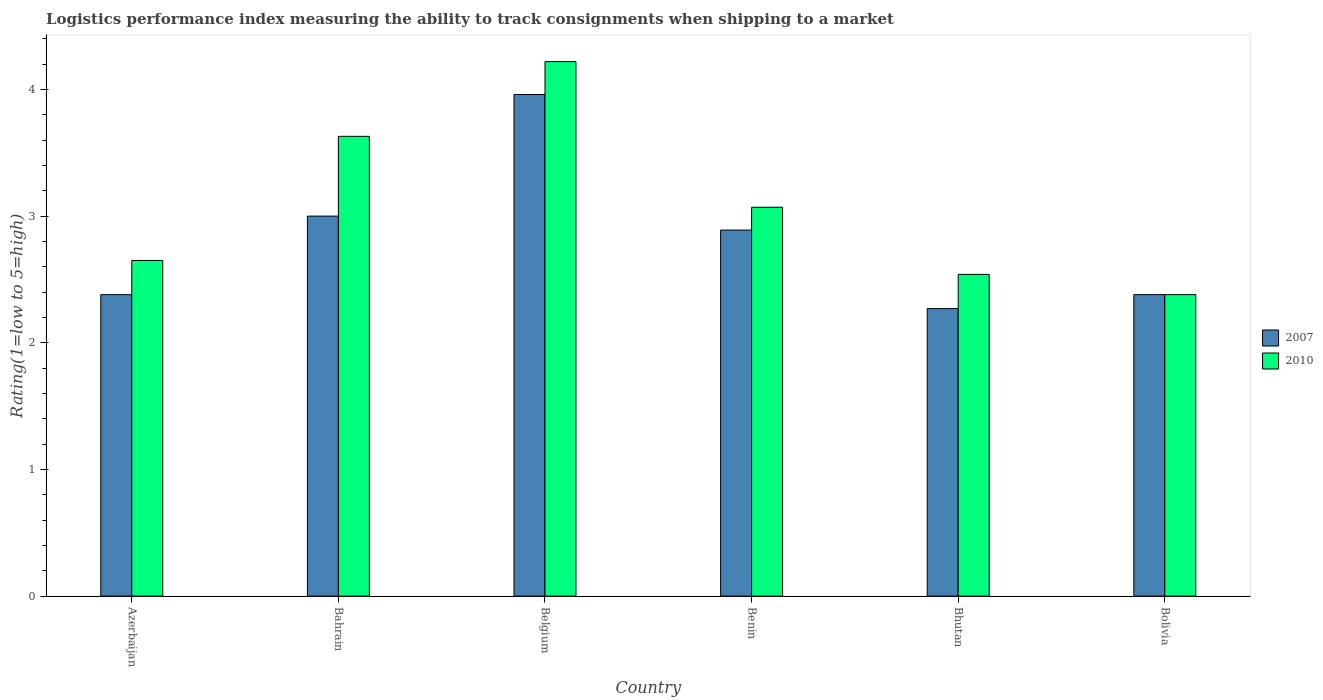How many groups of bars are there?
Provide a succinct answer. 6. How many bars are there on the 1st tick from the left?
Keep it short and to the point. 2. How many bars are there on the 3rd tick from the right?
Your answer should be compact. 2. What is the label of the 2nd group of bars from the left?
Give a very brief answer. Bahrain. What is the Logistic performance index in 2007 in Azerbaijan?
Ensure brevity in your answer.  2.38. Across all countries, what is the maximum Logistic performance index in 2010?
Make the answer very short. 4.22. Across all countries, what is the minimum Logistic performance index in 2010?
Your response must be concise. 2.38. In which country was the Logistic performance index in 2007 maximum?
Make the answer very short. Belgium. In which country was the Logistic performance index in 2007 minimum?
Your response must be concise. Bhutan. What is the total Logistic performance index in 2007 in the graph?
Give a very brief answer. 16.88. What is the difference between the Logistic performance index in 2010 in Bahrain and that in Belgium?
Provide a short and direct response. -0.59. What is the difference between the Logistic performance index in 2010 in Benin and the Logistic performance index in 2007 in Bahrain?
Make the answer very short. 0.07. What is the average Logistic performance index in 2007 per country?
Your answer should be compact. 2.81. What is the difference between the Logistic performance index of/in 2010 and Logistic performance index of/in 2007 in Bhutan?
Your response must be concise. 0.27. What is the ratio of the Logistic performance index in 2010 in Azerbaijan to that in Bahrain?
Make the answer very short. 0.73. Is the Logistic performance index in 2010 in Azerbaijan less than that in Bhutan?
Your answer should be very brief. No. What is the difference between the highest and the second highest Logistic performance index in 2007?
Your answer should be very brief. 0.11. What is the difference between the highest and the lowest Logistic performance index in 2007?
Offer a very short reply. 1.69. What does the 1st bar from the right in Belgium represents?
Ensure brevity in your answer.  2010. Are all the bars in the graph horizontal?
Offer a very short reply. No. How many countries are there in the graph?
Provide a short and direct response. 6. What is the difference between two consecutive major ticks on the Y-axis?
Your answer should be compact. 1. Are the values on the major ticks of Y-axis written in scientific E-notation?
Give a very brief answer. No. Does the graph contain grids?
Provide a succinct answer. No. Where does the legend appear in the graph?
Provide a succinct answer. Center right. What is the title of the graph?
Provide a succinct answer. Logistics performance index measuring the ability to track consignments when shipping to a market. What is the label or title of the Y-axis?
Keep it short and to the point. Rating(1=low to 5=high). What is the Rating(1=low to 5=high) of 2007 in Azerbaijan?
Make the answer very short. 2.38. What is the Rating(1=low to 5=high) of 2010 in Azerbaijan?
Keep it short and to the point. 2.65. What is the Rating(1=low to 5=high) of 2007 in Bahrain?
Keep it short and to the point. 3. What is the Rating(1=low to 5=high) of 2010 in Bahrain?
Your answer should be compact. 3.63. What is the Rating(1=low to 5=high) in 2007 in Belgium?
Your answer should be very brief. 3.96. What is the Rating(1=low to 5=high) of 2010 in Belgium?
Your response must be concise. 4.22. What is the Rating(1=low to 5=high) of 2007 in Benin?
Offer a very short reply. 2.89. What is the Rating(1=low to 5=high) of 2010 in Benin?
Provide a short and direct response. 3.07. What is the Rating(1=low to 5=high) of 2007 in Bhutan?
Provide a short and direct response. 2.27. What is the Rating(1=low to 5=high) in 2010 in Bhutan?
Provide a succinct answer. 2.54. What is the Rating(1=low to 5=high) of 2007 in Bolivia?
Offer a terse response. 2.38. What is the Rating(1=low to 5=high) of 2010 in Bolivia?
Offer a terse response. 2.38. Across all countries, what is the maximum Rating(1=low to 5=high) in 2007?
Offer a terse response. 3.96. Across all countries, what is the maximum Rating(1=low to 5=high) of 2010?
Make the answer very short. 4.22. Across all countries, what is the minimum Rating(1=low to 5=high) of 2007?
Provide a succinct answer. 2.27. Across all countries, what is the minimum Rating(1=low to 5=high) in 2010?
Ensure brevity in your answer.  2.38. What is the total Rating(1=low to 5=high) in 2007 in the graph?
Give a very brief answer. 16.88. What is the total Rating(1=low to 5=high) in 2010 in the graph?
Your answer should be very brief. 18.49. What is the difference between the Rating(1=low to 5=high) in 2007 in Azerbaijan and that in Bahrain?
Keep it short and to the point. -0.62. What is the difference between the Rating(1=low to 5=high) of 2010 in Azerbaijan and that in Bahrain?
Your response must be concise. -0.98. What is the difference between the Rating(1=low to 5=high) in 2007 in Azerbaijan and that in Belgium?
Provide a succinct answer. -1.58. What is the difference between the Rating(1=low to 5=high) of 2010 in Azerbaijan and that in Belgium?
Offer a very short reply. -1.57. What is the difference between the Rating(1=low to 5=high) in 2007 in Azerbaijan and that in Benin?
Keep it short and to the point. -0.51. What is the difference between the Rating(1=low to 5=high) in 2010 in Azerbaijan and that in Benin?
Give a very brief answer. -0.42. What is the difference between the Rating(1=low to 5=high) in 2007 in Azerbaijan and that in Bhutan?
Offer a terse response. 0.11. What is the difference between the Rating(1=low to 5=high) of 2010 in Azerbaijan and that in Bhutan?
Your answer should be very brief. 0.11. What is the difference between the Rating(1=low to 5=high) of 2010 in Azerbaijan and that in Bolivia?
Offer a very short reply. 0.27. What is the difference between the Rating(1=low to 5=high) in 2007 in Bahrain and that in Belgium?
Provide a succinct answer. -0.96. What is the difference between the Rating(1=low to 5=high) in 2010 in Bahrain and that in Belgium?
Provide a short and direct response. -0.59. What is the difference between the Rating(1=low to 5=high) in 2007 in Bahrain and that in Benin?
Provide a short and direct response. 0.11. What is the difference between the Rating(1=low to 5=high) in 2010 in Bahrain and that in Benin?
Give a very brief answer. 0.56. What is the difference between the Rating(1=low to 5=high) in 2007 in Bahrain and that in Bhutan?
Your response must be concise. 0.73. What is the difference between the Rating(1=low to 5=high) of 2010 in Bahrain and that in Bhutan?
Your response must be concise. 1.09. What is the difference between the Rating(1=low to 5=high) of 2007 in Bahrain and that in Bolivia?
Your response must be concise. 0.62. What is the difference between the Rating(1=low to 5=high) in 2010 in Bahrain and that in Bolivia?
Provide a succinct answer. 1.25. What is the difference between the Rating(1=low to 5=high) in 2007 in Belgium and that in Benin?
Offer a terse response. 1.07. What is the difference between the Rating(1=low to 5=high) of 2010 in Belgium and that in Benin?
Your answer should be very brief. 1.15. What is the difference between the Rating(1=low to 5=high) in 2007 in Belgium and that in Bhutan?
Your response must be concise. 1.69. What is the difference between the Rating(1=low to 5=high) of 2010 in Belgium and that in Bhutan?
Make the answer very short. 1.68. What is the difference between the Rating(1=low to 5=high) of 2007 in Belgium and that in Bolivia?
Provide a short and direct response. 1.58. What is the difference between the Rating(1=low to 5=high) in 2010 in Belgium and that in Bolivia?
Give a very brief answer. 1.84. What is the difference between the Rating(1=low to 5=high) of 2007 in Benin and that in Bhutan?
Your response must be concise. 0.62. What is the difference between the Rating(1=low to 5=high) of 2010 in Benin and that in Bhutan?
Your answer should be compact. 0.53. What is the difference between the Rating(1=low to 5=high) of 2007 in Benin and that in Bolivia?
Give a very brief answer. 0.51. What is the difference between the Rating(1=low to 5=high) of 2010 in Benin and that in Bolivia?
Give a very brief answer. 0.69. What is the difference between the Rating(1=low to 5=high) of 2007 in Bhutan and that in Bolivia?
Make the answer very short. -0.11. What is the difference between the Rating(1=low to 5=high) of 2010 in Bhutan and that in Bolivia?
Provide a succinct answer. 0.16. What is the difference between the Rating(1=low to 5=high) in 2007 in Azerbaijan and the Rating(1=low to 5=high) in 2010 in Bahrain?
Provide a succinct answer. -1.25. What is the difference between the Rating(1=low to 5=high) in 2007 in Azerbaijan and the Rating(1=low to 5=high) in 2010 in Belgium?
Ensure brevity in your answer.  -1.84. What is the difference between the Rating(1=low to 5=high) of 2007 in Azerbaijan and the Rating(1=low to 5=high) of 2010 in Benin?
Your answer should be very brief. -0.69. What is the difference between the Rating(1=low to 5=high) in 2007 in Azerbaijan and the Rating(1=low to 5=high) in 2010 in Bhutan?
Make the answer very short. -0.16. What is the difference between the Rating(1=low to 5=high) in 2007 in Bahrain and the Rating(1=low to 5=high) in 2010 in Belgium?
Your answer should be compact. -1.22. What is the difference between the Rating(1=low to 5=high) of 2007 in Bahrain and the Rating(1=low to 5=high) of 2010 in Benin?
Give a very brief answer. -0.07. What is the difference between the Rating(1=low to 5=high) of 2007 in Bahrain and the Rating(1=low to 5=high) of 2010 in Bhutan?
Keep it short and to the point. 0.46. What is the difference between the Rating(1=low to 5=high) in 2007 in Bahrain and the Rating(1=low to 5=high) in 2010 in Bolivia?
Provide a short and direct response. 0.62. What is the difference between the Rating(1=low to 5=high) of 2007 in Belgium and the Rating(1=low to 5=high) of 2010 in Benin?
Offer a very short reply. 0.89. What is the difference between the Rating(1=low to 5=high) of 2007 in Belgium and the Rating(1=low to 5=high) of 2010 in Bhutan?
Ensure brevity in your answer.  1.42. What is the difference between the Rating(1=low to 5=high) of 2007 in Belgium and the Rating(1=low to 5=high) of 2010 in Bolivia?
Your answer should be compact. 1.58. What is the difference between the Rating(1=low to 5=high) of 2007 in Benin and the Rating(1=low to 5=high) of 2010 in Bolivia?
Your response must be concise. 0.51. What is the difference between the Rating(1=low to 5=high) of 2007 in Bhutan and the Rating(1=low to 5=high) of 2010 in Bolivia?
Your answer should be compact. -0.11. What is the average Rating(1=low to 5=high) of 2007 per country?
Your answer should be compact. 2.81. What is the average Rating(1=low to 5=high) of 2010 per country?
Your answer should be very brief. 3.08. What is the difference between the Rating(1=low to 5=high) of 2007 and Rating(1=low to 5=high) of 2010 in Azerbaijan?
Keep it short and to the point. -0.27. What is the difference between the Rating(1=low to 5=high) in 2007 and Rating(1=low to 5=high) in 2010 in Bahrain?
Ensure brevity in your answer.  -0.63. What is the difference between the Rating(1=low to 5=high) in 2007 and Rating(1=low to 5=high) in 2010 in Belgium?
Provide a short and direct response. -0.26. What is the difference between the Rating(1=low to 5=high) in 2007 and Rating(1=low to 5=high) in 2010 in Benin?
Provide a short and direct response. -0.18. What is the difference between the Rating(1=low to 5=high) of 2007 and Rating(1=low to 5=high) of 2010 in Bhutan?
Your answer should be very brief. -0.27. What is the difference between the Rating(1=low to 5=high) in 2007 and Rating(1=low to 5=high) in 2010 in Bolivia?
Provide a succinct answer. 0. What is the ratio of the Rating(1=low to 5=high) of 2007 in Azerbaijan to that in Bahrain?
Ensure brevity in your answer.  0.79. What is the ratio of the Rating(1=low to 5=high) of 2010 in Azerbaijan to that in Bahrain?
Your response must be concise. 0.73. What is the ratio of the Rating(1=low to 5=high) in 2007 in Azerbaijan to that in Belgium?
Provide a short and direct response. 0.6. What is the ratio of the Rating(1=low to 5=high) of 2010 in Azerbaijan to that in Belgium?
Offer a terse response. 0.63. What is the ratio of the Rating(1=low to 5=high) in 2007 in Azerbaijan to that in Benin?
Give a very brief answer. 0.82. What is the ratio of the Rating(1=low to 5=high) in 2010 in Azerbaijan to that in Benin?
Provide a short and direct response. 0.86. What is the ratio of the Rating(1=low to 5=high) in 2007 in Azerbaijan to that in Bhutan?
Make the answer very short. 1.05. What is the ratio of the Rating(1=low to 5=high) in 2010 in Azerbaijan to that in Bhutan?
Make the answer very short. 1.04. What is the ratio of the Rating(1=low to 5=high) of 2007 in Azerbaijan to that in Bolivia?
Offer a terse response. 1. What is the ratio of the Rating(1=low to 5=high) of 2010 in Azerbaijan to that in Bolivia?
Provide a succinct answer. 1.11. What is the ratio of the Rating(1=low to 5=high) of 2007 in Bahrain to that in Belgium?
Provide a short and direct response. 0.76. What is the ratio of the Rating(1=low to 5=high) of 2010 in Bahrain to that in Belgium?
Give a very brief answer. 0.86. What is the ratio of the Rating(1=low to 5=high) in 2007 in Bahrain to that in Benin?
Your answer should be very brief. 1.04. What is the ratio of the Rating(1=low to 5=high) in 2010 in Bahrain to that in Benin?
Keep it short and to the point. 1.18. What is the ratio of the Rating(1=low to 5=high) in 2007 in Bahrain to that in Bhutan?
Your answer should be compact. 1.32. What is the ratio of the Rating(1=low to 5=high) in 2010 in Bahrain to that in Bhutan?
Provide a succinct answer. 1.43. What is the ratio of the Rating(1=low to 5=high) in 2007 in Bahrain to that in Bolivia?
Your answer should be very brief. 1.26. What is the ratio of the Rating(1=low to 5=high) of 2010 in Bahrain to that in Bolivia?
Provide a succinct answer. 1.53. What is the ratio of the Rating(1=low to 5=high) in 2007 in Belgium to that in Benin?
Your response must be concise. 1.37. What is the ratio of the Rating(1=low to 5=high) in 2010 in Belgium to that in Benin?
Your response must be concise. 1.37. What is the ratio of the Rating(1=low to 5=high) in 2007 in Belgium to that in Bhutan?
Provide a short and direct response. 1.74. What is the ratio of the Rating(1=low to 5=high) of 2010 in Belgium to that in Bhutan?
Offer a terse response. 1.66. What is the ratio of the Rating(1=low to 5=high) in 2007 in Belgium to that in Bolivia?
Your answer should be compact. 1.66. What is the ratio of the Rating(1=low to 5=high) of 2010 in Belgium to that in Bolivia?
Your answer should be very brief. 1.77. What is the ratio of the Rating(1=low to 5=high) of 2007 in Benin to that in Bhutan?
Give a very brief answer. 1.27. What is the ratio of the Rating(1=low to 5=high) in 2010 in Benin to that in Bhutan?
Your answer should be very brief. 1.21. What is the ratio of the Rating(1=low to 5=high) in 2007 in Benin to that in Bolivia?
Ensure brevity in your answer.  1.21. What is the ratio of the Rating(1=low to 5=high) of 2010 in Benin to that in Bolivia?
Ensure brevity in your answer.  1.29. What is the ratio of the Rating(1=low to 5=high) in 2007 in Bhutan to that in Bolivia?
Offer a terse response. 0.95. What is the ratio of the Rating(1=low to 5=high) in 2010 in Bhutan to that in Bolivia?
Give a very brief answer. 1.07. What is the difference between the highest and the second highest Rating(1=low to 5=high) in 2010?
Provide a succinct answer. 0.59. What is the difference between the highest and the lowest Rating(1=low to 5=high) of 2007?
Your answer should be compact. 1.69. What is the difference between the highest and the lowest Rating(1=low to 5=high) of 2010?
Ensure brevity in your answer.  1.84. 